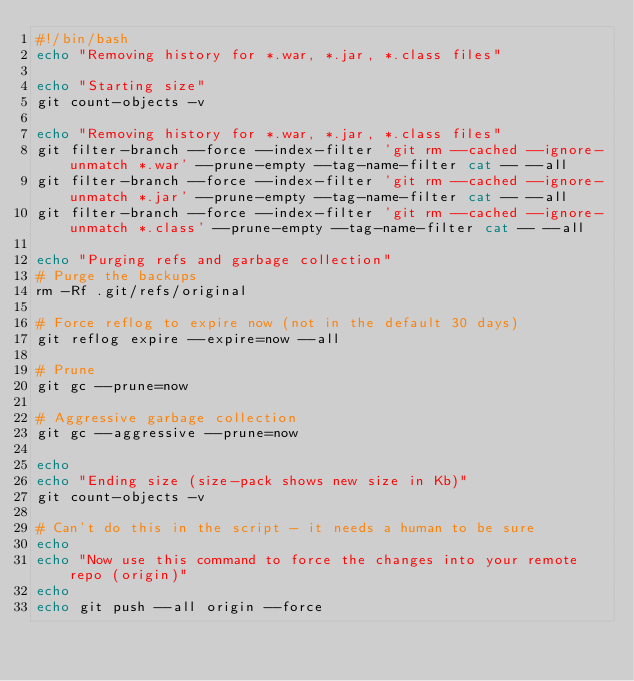Convert code to text. <code><loc_0><loc_0><loc_500><loc_500><_Bash_>#!/bin/bash
echo "Removing history for *.war, *.jar, *.class files"

echo "Starting size"
git count-objects -v

echo "Removing history for *.war, *.jar, *.class files"
git filter-branch --force --index-filter 'git rm --cached --ignore-unmatch *.war' --prune-empty --tag-name-filter cat -- --all
git filter-branch --force --index-filter 'git rm --cached --ignore-unmatch *.jar' --prune-empty --tag-name-filter cat -- --all
git filter-branch --force --index-filter 'git rm --cached --ignore-unmatch *.class' --prune-empty --tag-name-filter cat -- --all

echo "Purging refs and garbage collection"
# Purge the backups
rm -Rf .git/refs/original

# Force reflog to expire now (not in the default 30 days)
git reflog expire --expire=now --all

# Prune
git gc --prune=now

# Aggressive garbage collection
git gc --aggressive --prune=now

echo
echo "Ending size (size-pack shows new size in Kb)"
git count-objects -v

# Can't do this in the script - it needs a human to be sure
echo
echo "Now use this command to force the changes into your remote repo (origin)"
echo
echo git push --all origin --force</code> 